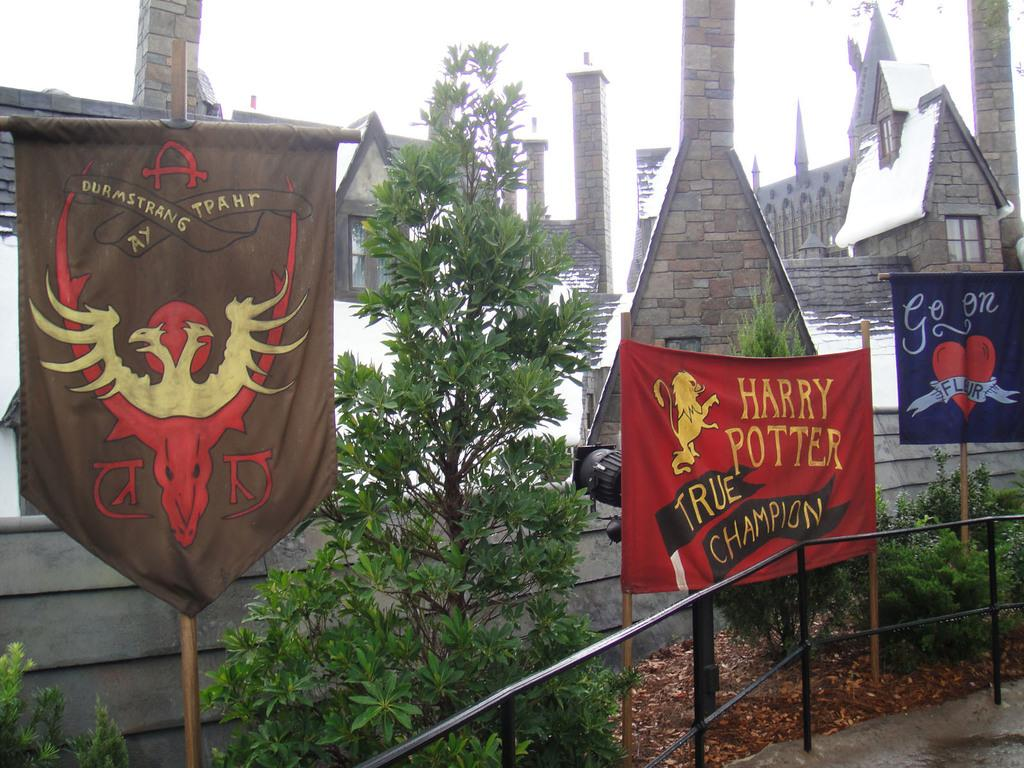<image>
Render a clear and concise summary of the photo. A banner for Harry Potter can be seen outside of a Hogwarts theme park 